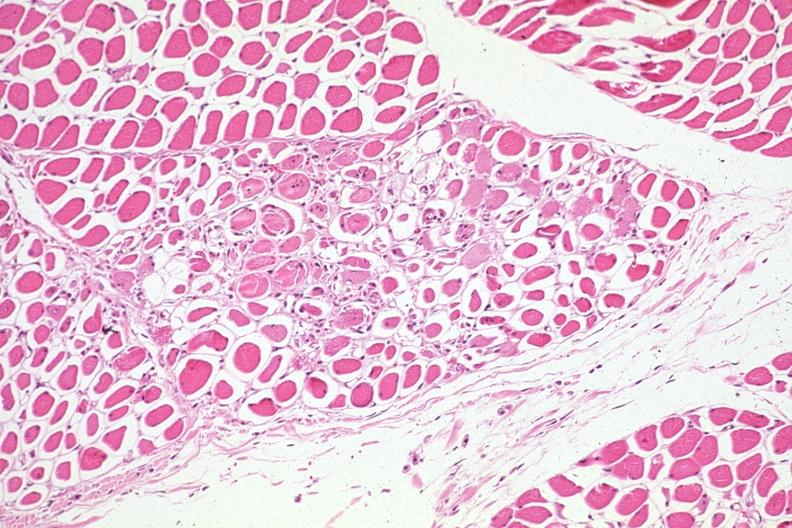does this image show lesions easily seen treated myelogenous leukemia complicated by infection and dic?
Answer the question using a single word or phrase. Yes 